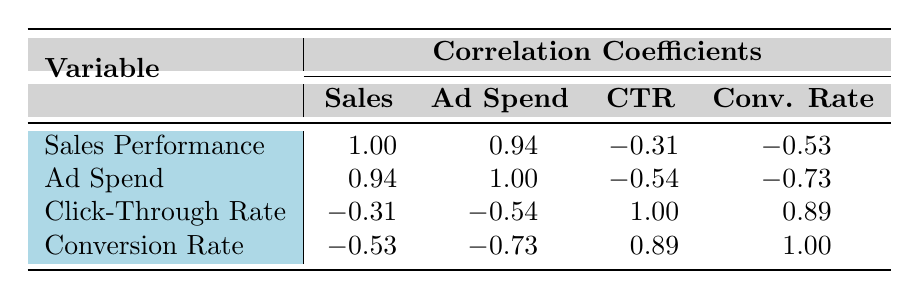What is the correlation coefficient between sales performance and ad spend? The table shows that the correlation coefficient between sales performance and ad spend is 0.94.
Answer: 0.94 Which advertising channel has the highest sales performance? From the table, Google Ads has the highest sales performance at 150000.
Answer: Google Ads Is there a negative correlation between click-through rate and sales performance? The correlation coefficient between click-through rate and sales performance is -0.31, which indicates a negative correlation.
Answer: Yes What is the average correlation between conversion rate and both ad spend and click-through rate? The conversion rate has a correlation coefficient of -0.73 with ad spend and 0.89 with click-through rate. The average correlation is (-0.73 + 0.89) / 2 = 0.08.
Answer: 0.08 Which advertising channel has the lowest conversion rate? The table shows that LinkedIn Ads has the lowest conversion rate at 0.01.
Answer: LinkedIn Ads Does increasing ad spend always result in higher sales performance? The correlation between ad spend and sales performance is 0.94, suggesting a strong positive relationship, but this does not imply causation; other factors may influence sales performance.
Answer: No What is the correlation coefficient between click-through rate and conversion rate? The table indicates that the correlation coefficient between click-through rate and conversion rate is 0.89.
Answer: 0.89 If sales performance is 100000, what is the average ad spend of channels that exceed this threshold? Only Google Ads exceeds this threshold, with an ad spend of 25000. Since there’s only one channel, the average is simply 25000.
Answer: 25000 What can be said about the relationship between ad spend and conversion rate? The correlation between ad spend and conversion rate is -0.73, indicating a strong negative correlation. As ad spend increases, the conversion rate tends to decrease.
Answer: Yes 